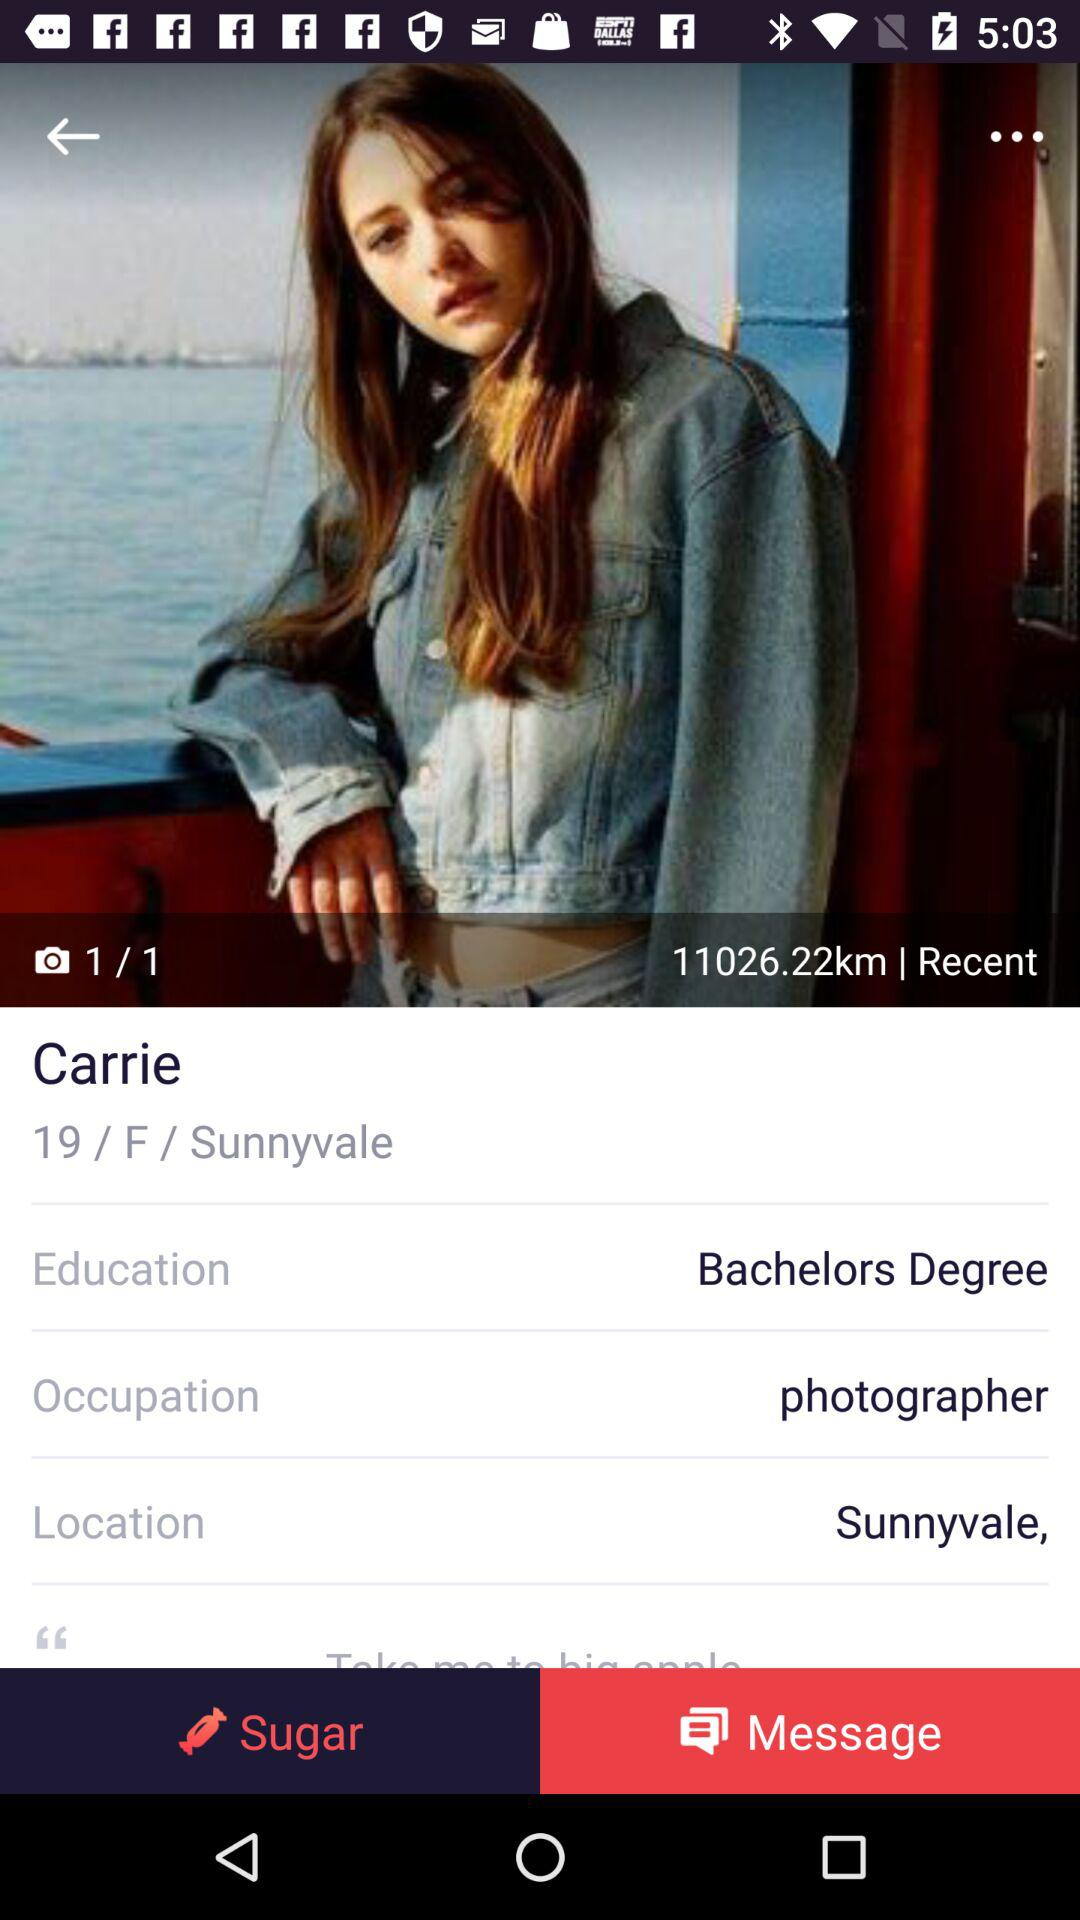What is the total number of photos? The total number of photos is 1. 